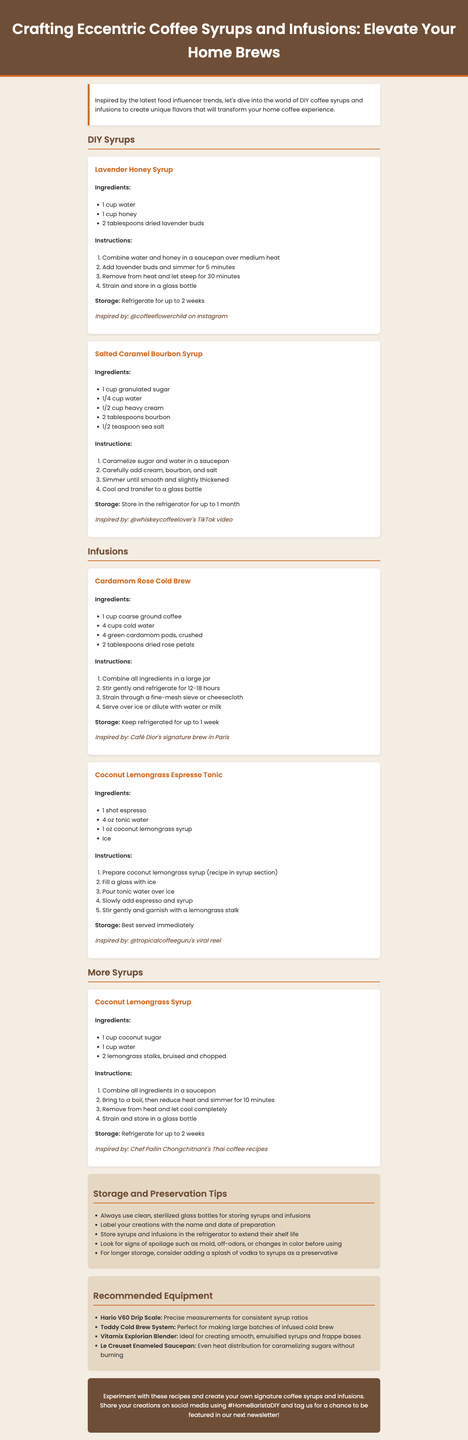What is the title of the newsletter? The title of the newsletter is given at the top of the document.
Answer: Crafting Eccentric Coffee Syrups and Infusions: Elevate Your Home Brews How long can Lavender Honey Syrup be stored? The storage advice for Lavender Honey Syrup indicates how long it can be kept.
Answer: Refrigerate for up to 2 weeks What ingredients are in Salted Caramel Bourbon Syrup? The ingredients are listed under the Salted Caramel Bourbon Syrup recipe in the document.
Answer: Sugar, water, cream, bourbon, sea salt How many hours should Cardamom Rose Cold Brew steep? The instructions for Cardamom Rose Cold Brew specify the steeping time.
Answer: 12-18 hours Which device is recommended for precise measurements? The equipment section outlines tools for various uses, including precise measurements.
Answer: Hario V60 Drip Scale What is the main flavor inspiration for Coconut Lemongrass Syrup? The document indicates the source of inspiration for various syrups.
Answer: Chef Pailin Chongchitnant's Thai coffee recipes What type of bottle should be used for storage? The storage tips mention the appropriate type of container for storing the syrups and infusions.
Answer: Clean, sterilized glass bottles What is the shelf life for Coconut Lemongrass Syrup? The storage advice predicts how long Coconut Lemongrass Syrup can be stored.
Answer: Refrigerate for up to 2 weeks 